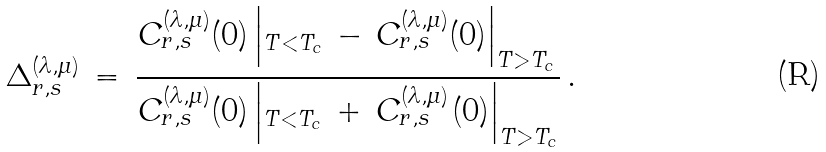Convert formula to latex. <formula><loc_0><loc_0><loc_500><loc_500>\Delta ^ { ( \lambda , \mu ) } _ { r , s } \, = \, \frac { C ^ { ( \lambda , \mu ) } _ { r , s } ( 0 ) \left | _ { T < T _ { c } } \, - \, C ^ { ( \lambda , \mu ) } _ { r , s } ( 0 ) \right | _ { T > T _ { c _ { \, } } } } { C ^ { ( \lambda , \mu ) } _ { r , s } ( 0 ) \left | _ { T < T _ { c } } \, + \, C ^ { ( \lambda , \mu ) ^ { \, } } _ { r , s } ( 0 ) \right | _ { T > T _ { c } } } \, .</formula> 